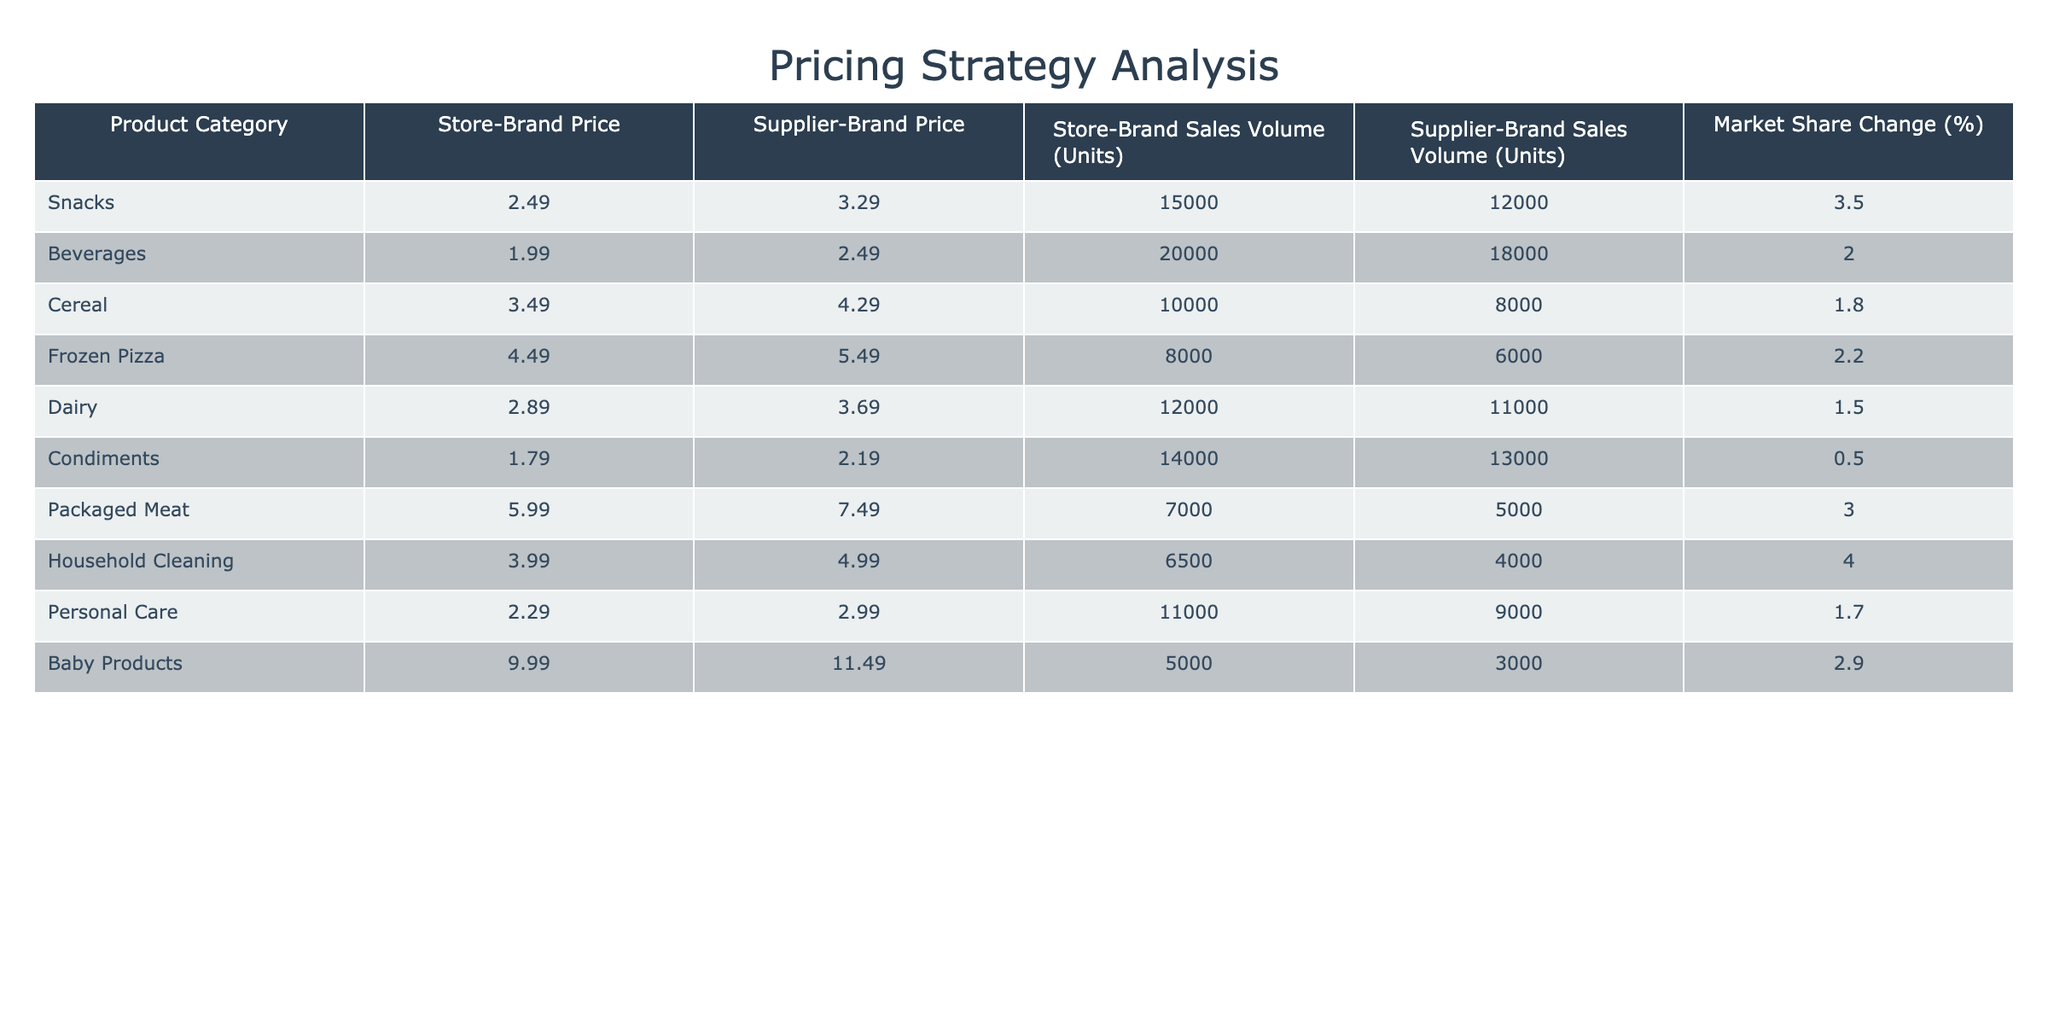What is the price difference between the store-brand and supplier-brand for snacks? The store-brand price for snacks is 2.49 and the supplier-brand price is 3.29. To find the price difference, subtract the store-brand price from the supplier-brand price: 3.29 - 2.49 = 0.80
Answer: 0.80 Which product category has the highest market share change? Looking at the "Market Share Change (%)" column, the highest value is 4.0% for Household Cleaning. This is the highest percentage compared to the other categories.
Answer: Household Cleaning What is the average sales volume for store-brand products? To find the average, sum the sales volumes for store-brands: (15000 + 20000 + 10000 + 8000 + 12000 + 14000 + 7000 + 6500 + 11000 + 5000) = 82500. There are 10 categories, so the average is 82500 / 10 = 8250.
Answer: 8250 Did the supplier-brand products have a higher sales volume in the beverages category compared to the dairy category? The sales volume for supplier-brand beverages is 18000 and for dairy, it is 11000. Since 18000 is greater than 11000, supplier-brand beverages had a higher sales volume.
Answer: Yes Which product category saw a decline in market share? By examining the "Market Share Change (%)", none of the product categories have negative changes. The lowest percentage is 0.5%, which indicates a slight gain rather than a decline.
Answer: No What is the total sales volume for supplier-brand products in the Cereal and Frozen Pizza categories combined? The sales volume for supplier-brand Cereal is 8000 and Frozen Pizza is 6000. Adding these together gives: 8000 + 6000 = 14000.
Answer: 14000 Which product category has the lowest supplier-brand price? By reviewing the "Supplier-Brand Price" column, the lowest price is 2.19 for Condiments. This is lower than all other categories.
Answer: Condiments Is the sales volume for store-brand baby products higher than the sales volume for supplier-brand packaged meat? The sales volume for store-brand baby products is 5000, while supplier-brand packaged meat sales volume is 5000 as well. Since they are equal, the comparison shows that they are not higher.
Answer: No What is the combined market share change for Snacks and Dairy categories? The market share change for Snacks is 3.5% and for Dairy it is 1.5%. Adding these percentages gives: 3.5 + 1.5 = 5.0%. Thus, the combined market share change is 5.0%.
Answer: 5.0 